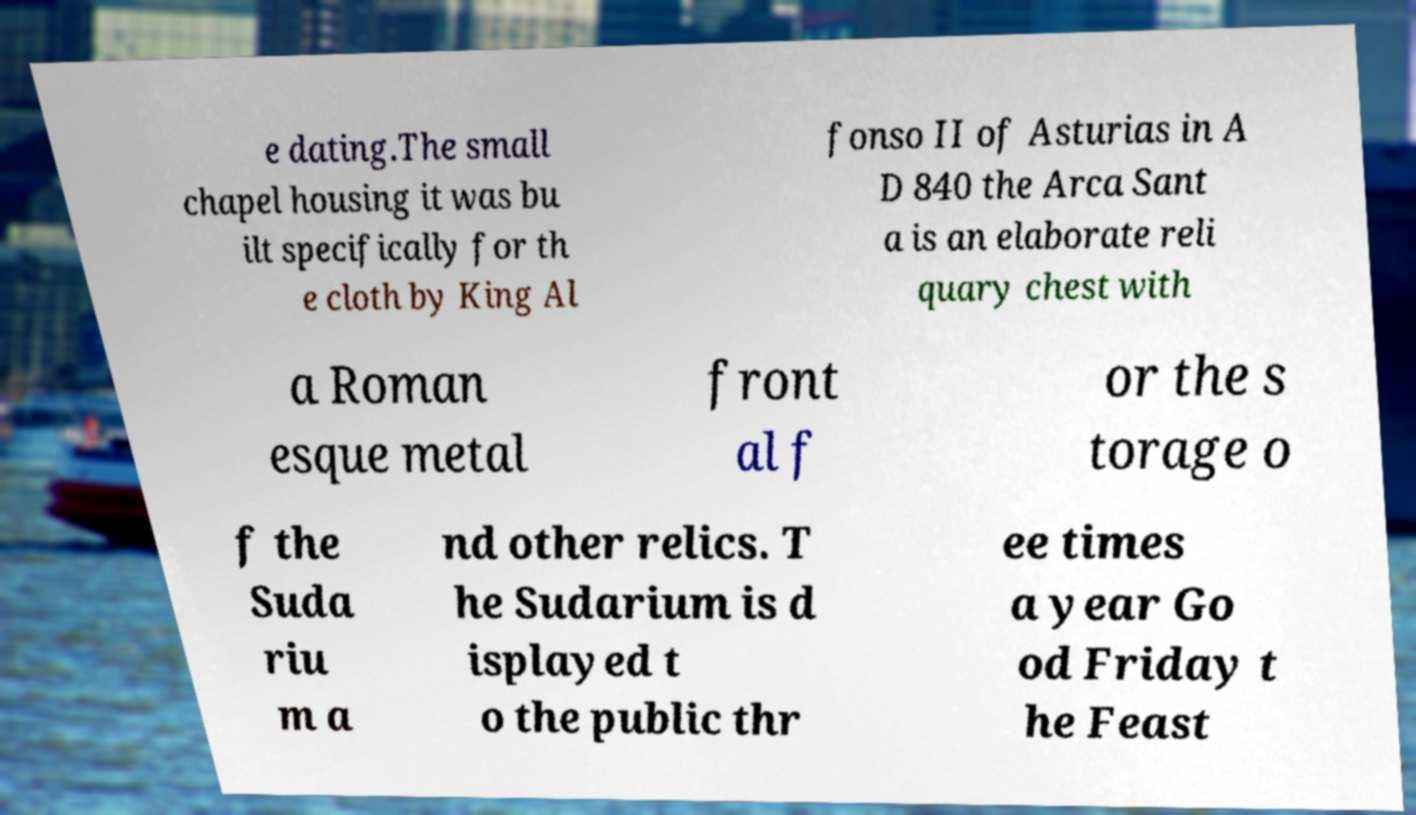Can you read and provide the text displayed in the image?This photo seems to have some interesting text. Can you extract and type it out for me? e dating.The small chapel housing it was bu ilt specifically for th e cloth by King Al fonso II of Asturias in A D 840 the Arca Sant a is an elaborate reli quary chest with a Roman esque metal front al f or the s torage o f the Suda riu m a nd other relics. T he Sudarium is d isplayed t o the public thr ee times a year Go od Friday t he Feast 